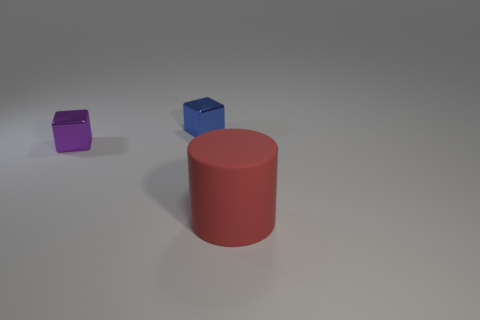What color is the metal thing that is in front of the shiny object right of the tiny metallic thing in front of the blue shiny thing? purple 